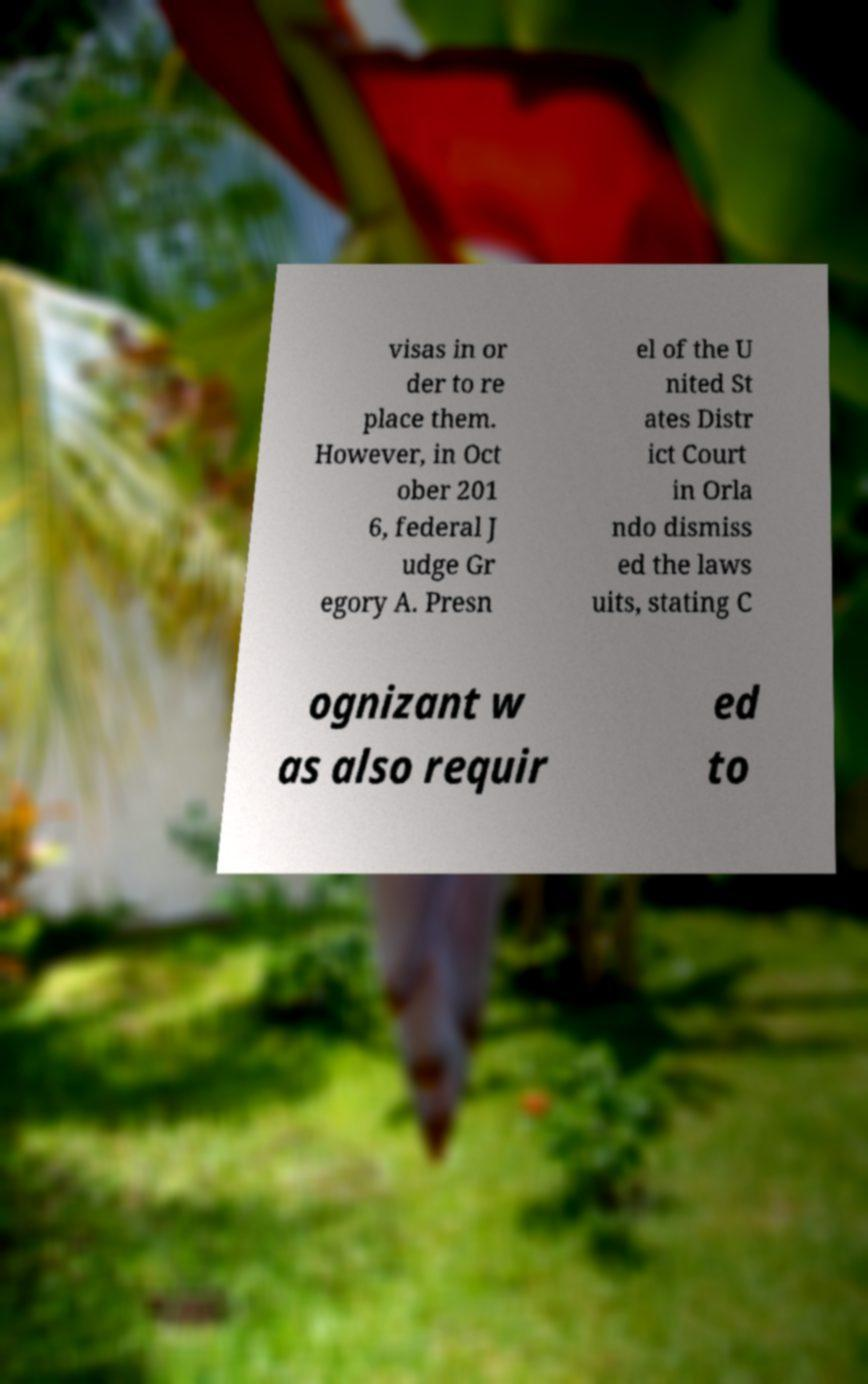Please read and relay the text visible in this image. What does it say? visas in or der to re place them. However, in Oct ober 201 6, federal J udge Gr egory A. Presn el of the U nited St ates Distr ict Court in Orla ndo dismiss ed the laws uits, stating C ognizant w as also requir ed to 